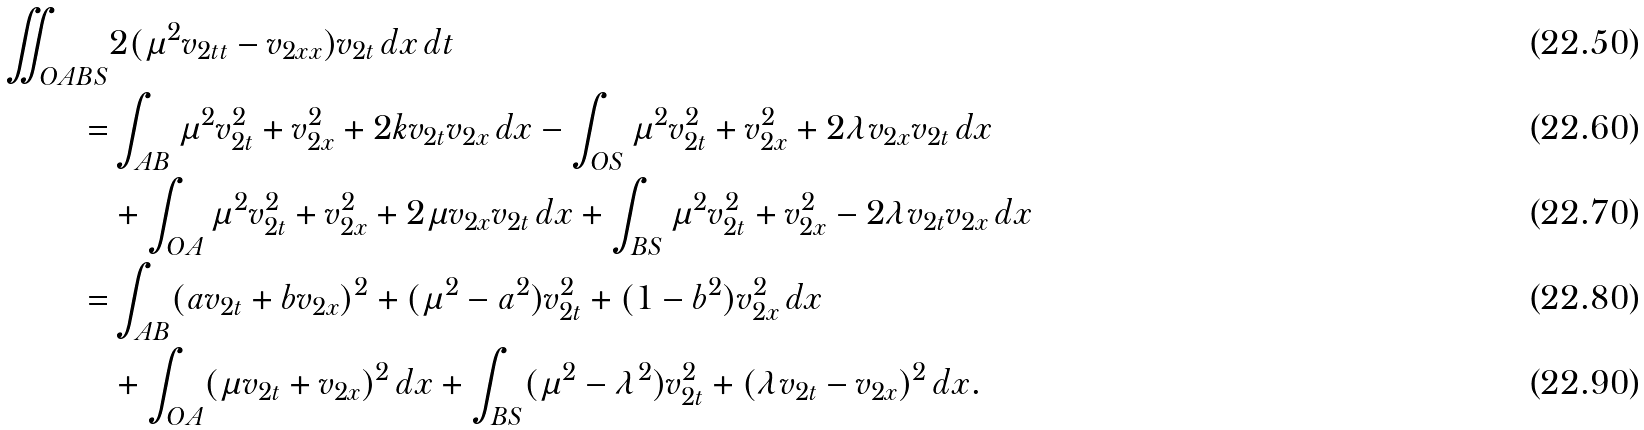<formula> <loc_0><loc_0><loc_500><loc_500>\iint _ { O A B S } & 2 ( \mu ^ { 2 } v _ { 2 t t } - v _ { 2 x x } ) v _ { 2 t } \, d x \, d t \\ = & \int _ { A B } \mu ^ { 2 } v _ { 2 t } ^ { 2 } + v _ { 2 x } ^ { 2 } + 2 k v _ { 2 t } v _ { 2 x } \, d x - \int _ { O S } \mu ^ { 2 } v _ { 2 t } ^ { 2 } + v _ { 2 x } ^ { 2 } + 2 \lambda v _ { 2 x } v _ { 2 t } \, d x \\ & + \int _ { O A } \mu ^ { 2 } v _ { 2 t } ^ { 2 } + v _ { 2 x } ^ { 2 } + 2 \mu v _ { 2 x } v _ { 2 t } \, d x + \int _ { B S } \mu ^ { 2 } v _ { 2 t } ^ { 2 } + v _ { 2 x } ^ { 2 } - 2 \lambda v _ { 2 t } v _ { 2 x } \, d x \\ = & \int _ { A B } ( a v _ { 2 t } + b v _ { 2 x } ) ^ { 2 } + ( \mu ^ { 2 } - a ^ { 2 } ) v _ { 2 t } ^ { 2 } + ( 1 - b ^ { 2 } ) v _ { 2 x } ^ { 2 } \, d x \\ & + \int _ { O A } ( \mu v _ { 2 t } + v _ { 2 x } ) ^ { 2 } \, d x + \int _ { B S } ( \mu ^ { 2 } - \lambda ^ { 2 } ) v _ { 2 t } ^ { 2 } + ( \lambda v _ { 2 t } - v _ { 2 x } ) ^ { 2 } \, d x .</formula> 